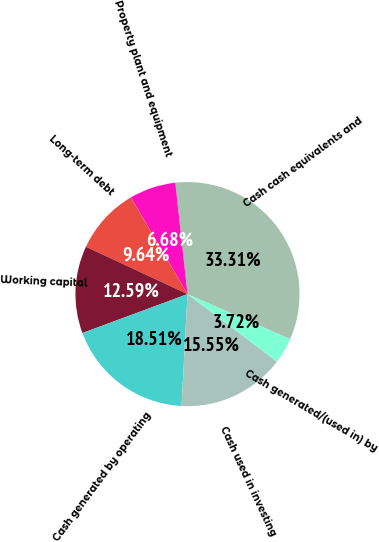Convert chart to OTSL. <chart><loc_0><loc_0><loc_500><loc_500><pie_chart><fcel>Cash cash equivalents and<fcel>Property plant and equipment<fcel>Long-term debt<fcel>Working capital<fcel>Cash generated by operating<fcel>Cash used in investing<fcel>Cash generated/(used in) by<nl><fcel>33.31%<fcel>6.68%<fcel>9.64%<fcel>12.59%<fcel>18.51%<fcel>15.55%<fcel>3.72%<nl></chart> 